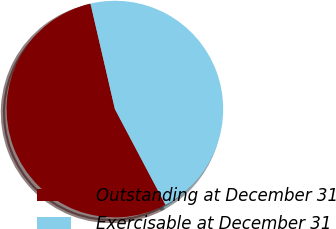Convert chart. <chart><loc_0><loc_0><loc_500><loc_500><pie_chart><fcel>Outstanding at December 31<fcel>Exercisable at December 31<nl><fcel>54.12%<fcel>45.88%<nl></chart> 